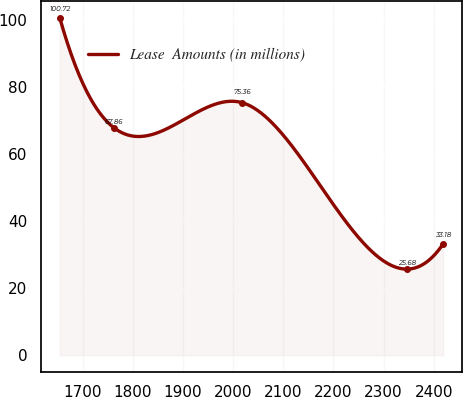Convert chart. <chart><loc_0><loc_0><loc_500><loc_500><line_chart><ecel><fcel>Lease  Amounts (in millions)<nl><fcel>1653.88<fcel>100.72<nl><fcel>1762.17<fcel>67.86<nl><fcel>2018.06<fcel>75.36<nl><fcel>2346.31<fcel>25.68<nl><fcel>2418.69<fcel>33.18<nl></chart> 